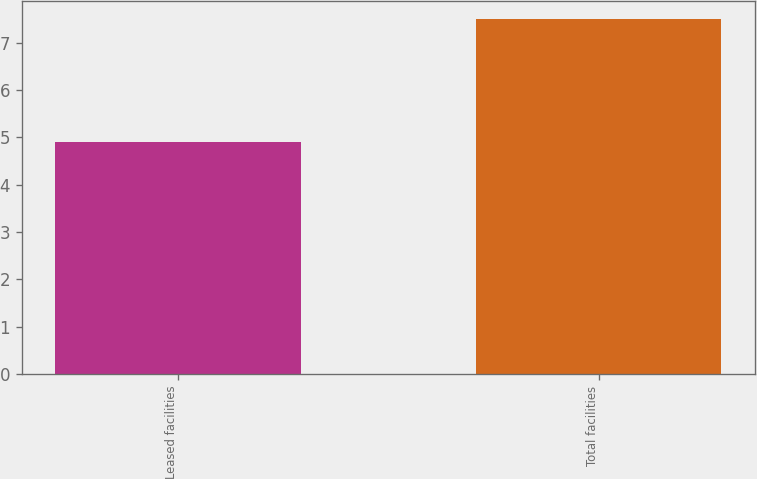<chart> <loc_0><loc_0><loc_500><loc_500><bar_chart><fcel>Leased facilities<fcel>Total facilities<nl><fcel>4.9<fcel>7.5<nl></chart> 